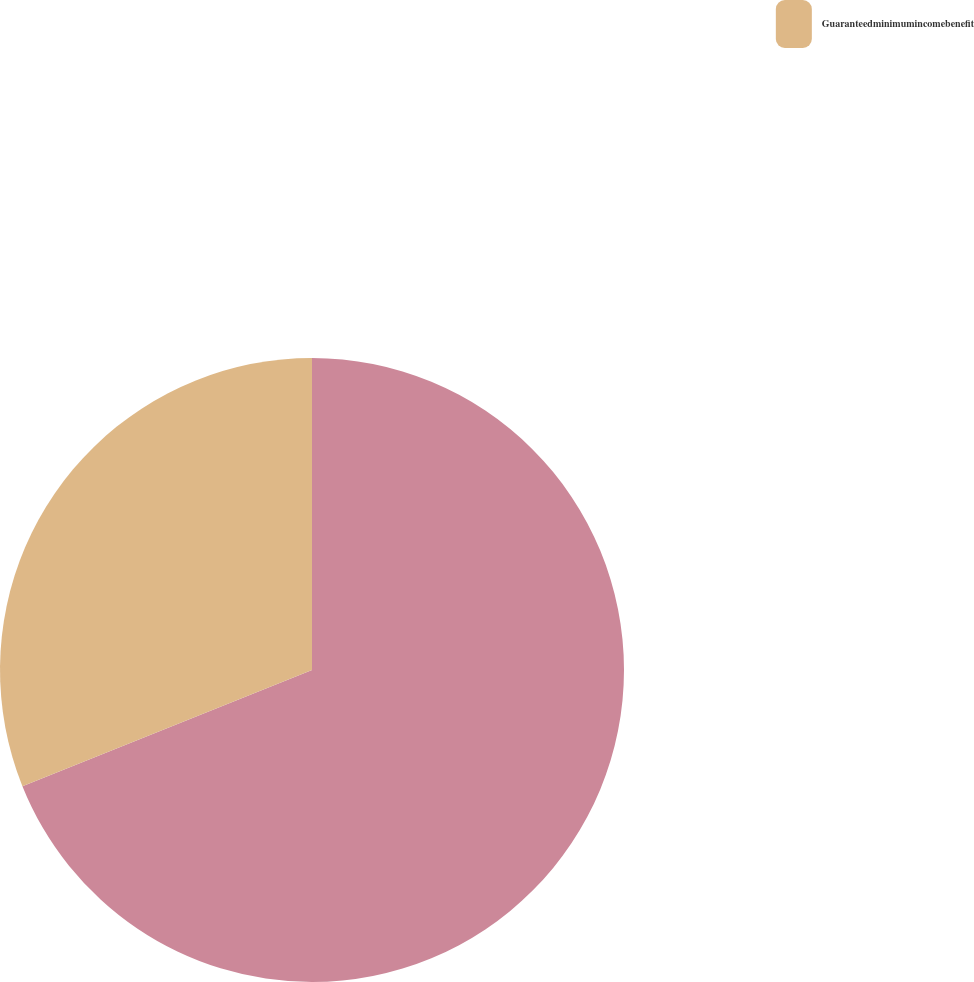Convert chart. <chart><loc_0><loc_0><loc_500><loc_500><pie_chart><ecel><fcel>Guaranteedminimumincomebenefit<nl><fcel>68.93%<fcel>31.07%<nl></chart> 